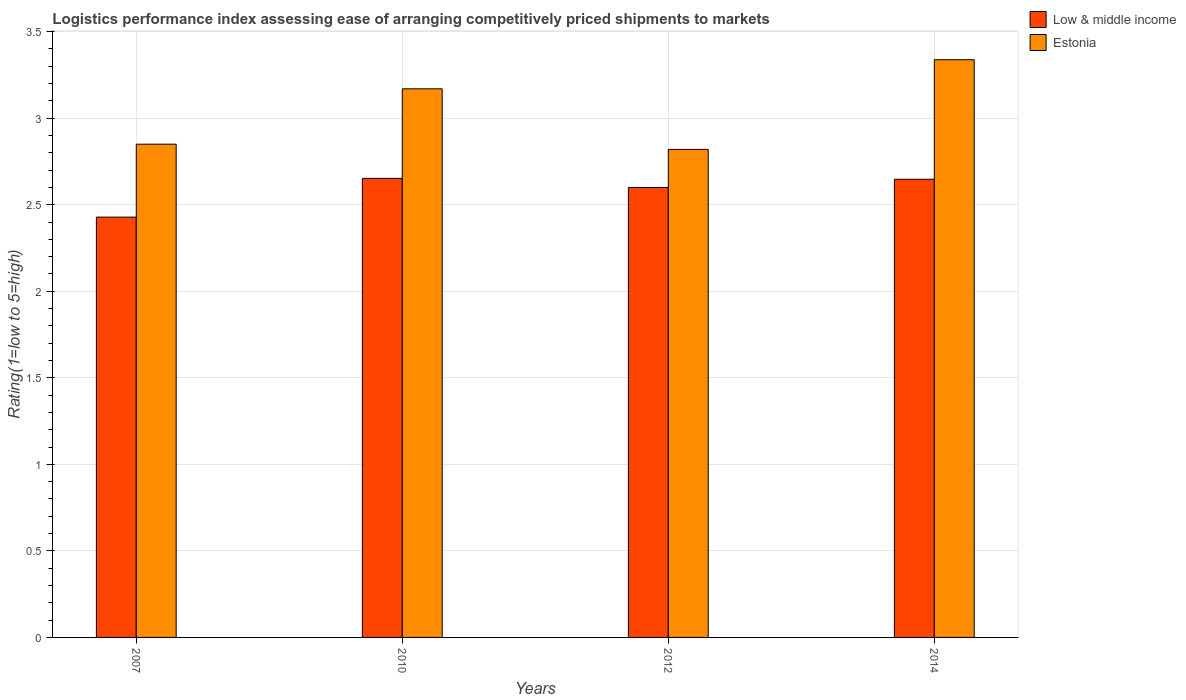Are the number of bars on each tick of the X-axis equal?
Offer a very short reply. Yes. How many bars are there on the 2nd tick from the left?
Keep it short and to the point. 2. What is the label of the 3rd group of bars from the left?
Your response must be concise. 2012. In how many cases, is the number of bars for a given year not equal to the number of legend labels?
Offer a terse response. 0. What is the Logistic performance index in Estonia in 2012?
Offer a terse response. 2.82. Across all years, what is the maximum Logistic performance index in Low & middle income?
Provide a short and direct response. 2.65. Across all years, what is the minimum Logistic performance index in Low & middle income?
Your answer should be compact. 2.43. In which year was the Logistic performance index in Low & middle income maximum?
Keep it short and to the point. 2010. In which year was the Logistic performance index in Estonia minimum?
Ensure brevity in your answer.  2012. What is the total Logistic performance index in Estonia in the graph?
Provide a short and direct response. 12.18. What is the difference between the Logistic performance index in Estonia in 2010 and that in 2014?
Offer a terse response. -0.17. What is the difference between the Logistic performance index in Estonia in 2007 and the Logistic performance index in Low & middle income in 2012?
Make the answer very short. 0.25. What is the average Logistic performance index in Estonia per year?
Make the answer very short. 3.04. In the year 2007, what is the difference between the Logistic performance index in Estonia and Logistic performance index in Low & middle income?
Keep it short and to the point. 0.42. In how many years, is the Logistic performance index in Low & middle income greater than 1.4?
Offer a terse response. 4. What is the ratio of the Logistic performance index in Estonia in 2010 to that in 2012?
Give a very brief answer. 1.12. Is the difference between the Logistic performance index in Estonia in 2010 and 2014 greater than the difference between the Logistic performance index in Low & middle income in 2010 and 2014?
Provide a succinct answer. No. What is the difference between the highest and the second highest Logistic performance index in Low & middle income?
Your answer should be very brief. 0.01. What is the difference between the highest and the lowest Logistic performance index in Estonia?
Provide a succinct answer. 0.52. Is the sum of the Logistic performance index in Low & middle income in 2007 and 2014 greater than the maximum Logistic performance index in Estonia across all years?
Give a very brief answer. Yes. What does the 2nd bar from the left in 2007 represents?
Keep it short and to the point. Estonia. What does the 2nd bar from the right in 2012 represents?
Offer a terse response. Low & middle income. How many bars are there?
Offer a terse response. 8. Are all the bars in the graph horizontal?
Your answer should be compact. No. How many years are there in the graph?
Provide a succinct answer. 4. Are the values on the major ticks of Y-axis written in scientific E-notation?
Your response must be concise. No. Does the graph contain grids?
Your answer should be compact. Yes. Where does the legend appear in the graph?
Your response must be concise. Top right. How are the legend labels stacked?
Your answer should be compact. Vertical. What is the title of the graph?
Provide a short and direct response. Logistics performance index assessing ease of arranging competitively priced shipments to markets. What is the label or title of the Y-axis?
Offer a very short reply. Rating(1=low to 5=high). What is the Rating(1=low to 5=high) of Low & middle income in 2007?
Your answer should be very brief. 2.43. What is the Rating(1=low to 5=high) of Estonia in 2007?
Make the answer very short. 2.85. What is the Rating(1=low to 5=high) in Low & middle income in 2010?
Offer a very short reply. 2.65. What is the Rating(1=low to 5=high) of Estonia in 2010?
Your response must be concise. 3.17. What is the Rating(1=low to 5=high) of Low & middle income in 2012?
Your response must be concise. 2.6. What is the Rating(1=low to 5=high) of Estonia in 2012?
Your response must be concise. 2.82. What is the Rating(1=low to 5=high) of Low & middle income in 2014?
Give a very brief answer. 2.65. What is the Rating(1=low to 5=high) of Estonia in 2014?
Keep it short and to the point. 3.34. Across all years, what is the maximum Rating(1=low to 5=high) in Low & middle income?
Your answer should be compact. 2.65. Across all years, what is the maximum Rating(1=low to 5=high) of Estonia?
Make the answer very short. 3.34. Across all years, what is the minimum Rating(1=low to 5=high) in Low & middle income?
Ensure brevity in your answer.  2.43. Across all years, what is the minimum Rating(1=low to 5=high) in Estonia?
Ensure brevity in your answer.  2.82. What is the total Rating(1=low to 5=high) in Low & middle income in the graph?
Give a very brief answer. 10.33. What is the total Rating(1=low to 5=high) in Estonia in the graph?
Your response must be concise. 12.18. What is the difference between the Rating(1=low to 5=high) of Low & middle income in 2007 and that in 2010?
Your response must be concise. -0.22. What is the difference between the Rating(1=low to 5=high) of Estonia in 2007 and that in 2010?
Offer a terse response. -0.32. What is the difference between the Rating(1=low to 5=high) in Low & middle income in 2007 and that in 2012?
Offer a terse response. -0.17. What is the difference between the Rating(1=low to 5=high) of Low & middle income in 2007 and that in 2014?
Provide a succinct answer. -0.22. What is the difference between the Rating(1=low to 5=high) in Estonia in 2007 and that in 2014?
Your response must be concise. -0.49. What is the difference between the Rating(1=low to 5=high) of Low & middle income in 2010 and that in 2012?
Offer a terse response. 0.05. What is the difference between the Rating(1=low to 5=high) in Estonia in 2010 and that in 2012?
Offer a terse response. 0.35. What is the difference between the Rating(1=low to 5=high) of Low & middle income in 2010 and that in 2014?
Offer a terse response. 0.01. What is the difference between the Rating(1=low to 5=high) of Estonia in 2010 and that in 2014?
Offer a very short reply. -0.17. What is the difference between the Rating(1=low to 5=high) of Low & middle income in 2012 and that in 2014?
Your answer should be compact. -0.05. What is the difference between the Rating(1=low to 5=high) in Estonia in 2012 and that in 2014?
Your response must be concise. -0.52. What is the difference between the Rating(1=low to 5=high) in Low & middle income in 2007 and the Rating(1=low to 5=high) in Estonia in 2010?
Offer a very short reply. -0.74. What is the difference between the Rating(1=low to 5=high) in Low & middle income in 2007 and the Rating(1=low to 5=high) in Estonia in 2012?
Keep it short and to the point. -0.39. What is the difference between the Rating(1=low to 5=high) in Low & middle income in 2007 and the Rating(1=low to 5=high) in Estonia in 2014?
Ensure brevity in your answer.  -0.91. What is the difference between the Rating(1=low to 5=high) in Low & middle income in 2010 and the Rating(1=low to 5=high) in Estonia in 2012?
Your response must be concise. -0.17. What is the difference between the Rating(1=low to 5=high) in Low & middle income in 2010 and the Rating(1=low to 5=high) in Estonia in 2014?
Provide a short and direct response. -0.69. What is the difference between the Rating(1=low to 5=high) of Low & middle income in 2012 and the Rating(1=low to 5=high) of Estonia in 2014?
Keep it short and to the point. -0.74. What is the average Rating(1=low to 5=high) of Low & middle income per year?
Your response must be concise. 2.58. What is the average Rating(1=low to 5=high) of Estonia per year?
Make the answer very short. 3.04. In the year 2007, what is the difference between the Rating(1=low to 5=high) of Low & middle income and Rating(1=low to 5=high) of Estonia?
Make the answer very short. -0.42. In the year 2010, what is the difference between the Rating(1=low to 5=high) in Low & middle income and Rating(1=low to 5=high) in Estonia?
Make the answer very short. -0.52. In the year 2012, what is the difference between the Rating(1=low to 5=high) of Low & middle income and Rating(1=low to 5=high) of Estonia?
Your response must be concise. -0.22. In the year 2014, what is the difference between the Rating(1=low to 5=high) in Low & middle income and Rating(1=low to 5=high) in Estonia?
Your answer should be compact. -0.69. What is the ratio of the Rating(1=low to 5=high) in Low & middle income in 2007 to that in 2010?
Offer a terse response. 0.92. What is the ratio of the Rating(1=low to 5=high) of Estonia in 2007 to that in 2010?
Offer a terse response. 0.9. What is the ratio of the Rating(1=low to 5=high) of Low & middle income in 2007 to that in 2012?
Give a very brief answer. 0.93. What is the ratio of the Rating(1=low to 5=high) in Estonia in 2007 to that in 2012?
Your answer should be compact. 1.01. What is the ratio of the Rating(1=low to 5=high) in Low & middle income in 2007 to that in 2014?
Your answer should be compact. 0.92. What is the ratio of the Rating(1=low to 5=high) of Estonia in 2007 to that in 2014?
Offer a very short reply. 0.85. What is the ratio of the Rating(1=low to 5=high) of Low & middle income in 2010 to that in 2012?
Your response must be concise. 1.02. What is the ratio of the Rating(1=low to 5=high) in Estonia in 2010 to that in 2012?
Give a very brief answer. 1.12. What is the ratio of the Rating(1=low to 5=high) of Low & middle income in 2010 to that in 2014?
Make the answer very short. 1. What is the ratio of the Rating(1=low to 5=high) of Estonia in 2010 to that in 2014?
Ensure brevity in your answer.  0.95. What is the ratio of the Rating(1=low to 5=high) of Low & middle income in 2012 to that in 2014?
Your response must be concise. 0.98. What is the ratio of the Rating(1=low to 5=high) in Estonia in 2012 to that in 2014?
Give a very brief answer. 0.84. What is the difference between the highest and the second highest Rating(1=low to 5=high) of Low & middle income?
Ensure brevity in your answer.  0.01. What is the difference between the highest and the second highest Rating(1=low to 5=high) of Estonia?
Your answer should be very brief. 0.17. What is the difference between the highest and the lowest Rating(1=low to 5=high) of Low & middle income?
Ensure brevity in your answer.  0.22. What is the difference between the highest and the lowest Rating(1=low to 5=high) in Estonia?
Provide a succinct answer. 0.52. 